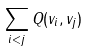<formula> <loc_0><loc_0><loc_500><loc_500>\sum _ { i < j } Q ( v _ { i } , v _ { j } )</formula> 